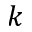<formula> <loc_0><loc_0><loc_500><loc_500>k</formula> 